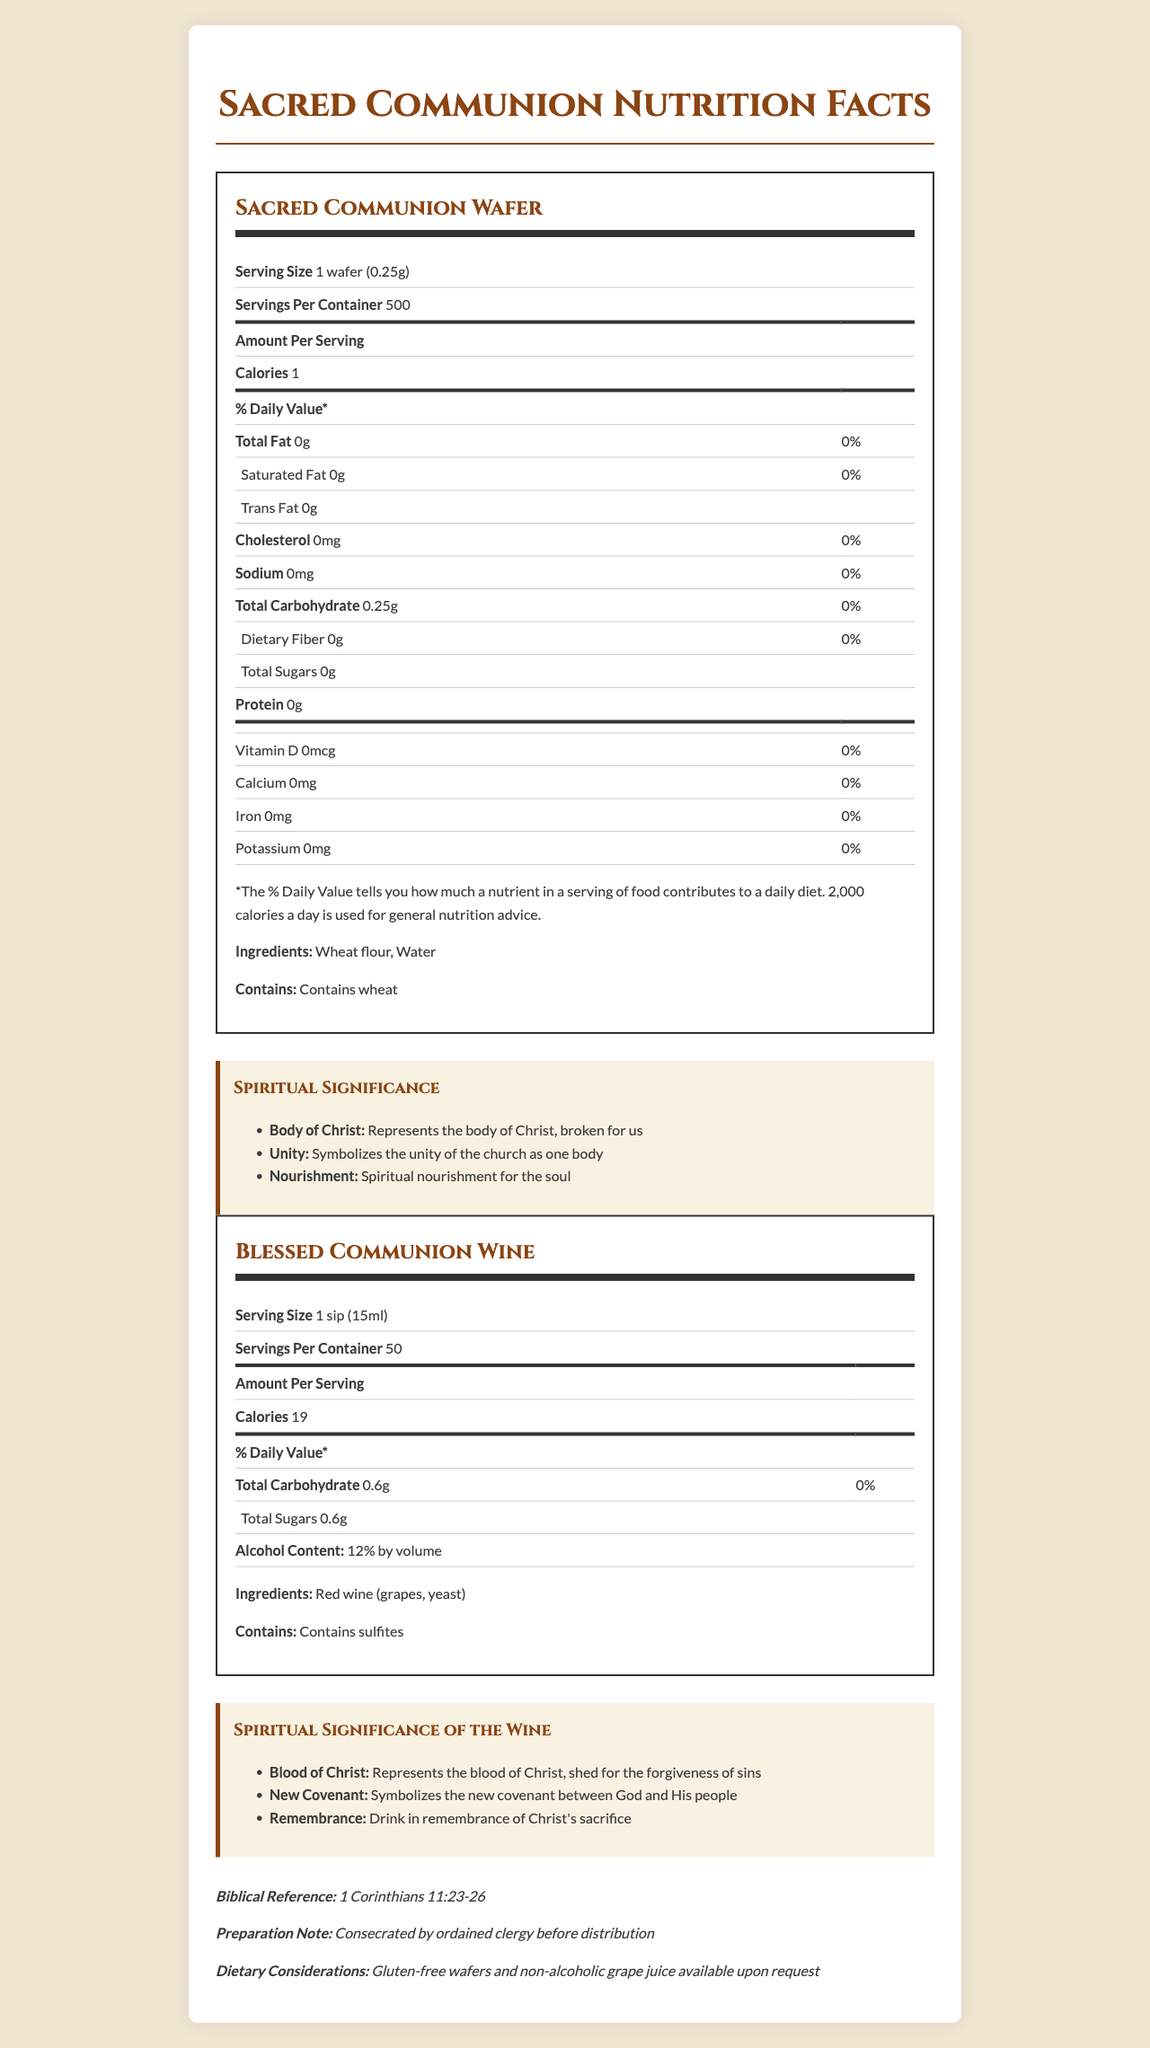what is the serving size of the Sacred Communion Wafer? The document states the serving size directly under the product name for the Sacred Communion Wafer.
Answer: 1 wafer (0.25g) what does the Sacred Communion Wafer symbolize in terms of spiritual nourishment? The spiritual significance section under the Sacred Communion Wafer lists this as the first point.
Answer: Represents the body of Christ, broken for us how many servings are in one container of the Blessed Communion Wine? The document states the servings per container under the product name for the Blessed Communion Wine.
Answer: 50 what allergens are present in the Sacred Communion Wafer and Blessed Communion Wine? The document lists allergens at the end of each product's nutritional information.
Answer: Sacred Communion Wafer: Wheat, Blessed Communion Wine: Sulfites what is the calorie content of one serving of Sacred Communion Wafer? The calories per serving are listed in the nutritional information table for the Sacred Communion Wafer.
Answer: 1 calorie does the Blessed Communion Wine contain any alcohol? The document states "Alcohol Content: 12% by volume" in the nutritional information section for the Blessed Communion Wine.
Answer: Yes how does the Blessed Communion Wine symbolize the new covenant? This is listed under the spiritual significance section of the Blessed Communion Wine.
Answer: Symbolizes the new covenant between God and His people how much total carbohydrate is there in one serving of Sacred Communion Wafer? A. 0g B. 0.25g C. 1g D. 10g The document states the total carbohydrate content in the nutritional information table for the Sacred Communion Wafer.
Answer: B which of the following ingredients is NOT found in Sacred Communion Wafer? A. Wheat flour B. Water C. Yeast D. All of the above The ingredients for Sacred Communion Wafer are listed as wheat flour and water.
Answer: C are there any gluten-free options available? The document mentions that gluten-free wafers and non-alcoholic grape juice are available upon request in the dietary considerations section.
Answer: Yes describe the main idea of the document. The document is structured to present both the nutritional content and the spiritual importance of communion elements, emphasizing their role in Christian rituals, unity of the church, and spiritual nourishment.
Answer: The document provides detailed nutritional information and spiritual significance for Sacred Communion Wafer and Blessed Communion Wine, along with dietary considerations, biblical references, and preparation notes. what is the protein content of the Sacred Communion Wafer? The nutritional information table for the Sacred Communion Wafer shows 0g of protein per serving.
Answer: 0g what reference is provided to support the spiritual significance of the communion elements? The biblical reference is listed in the additional information section of the document.
Answer: 1 Corinthians 11:23-26 how many total sugars are in one sip of the Blessed Communion Wine? A. 0.6g B. 1g C. 2g D. 5g The nutritional information for Blessed Communion Wine lists the total sugars as 0.6g per sip.
Answer: A what is the purpose of the document? The document provides information about Sacred and Communion Wafers, but the purpose behind its creation (e.g., for information, sales, educational) is not explicitly stated.
Answer: Cannot be determined 